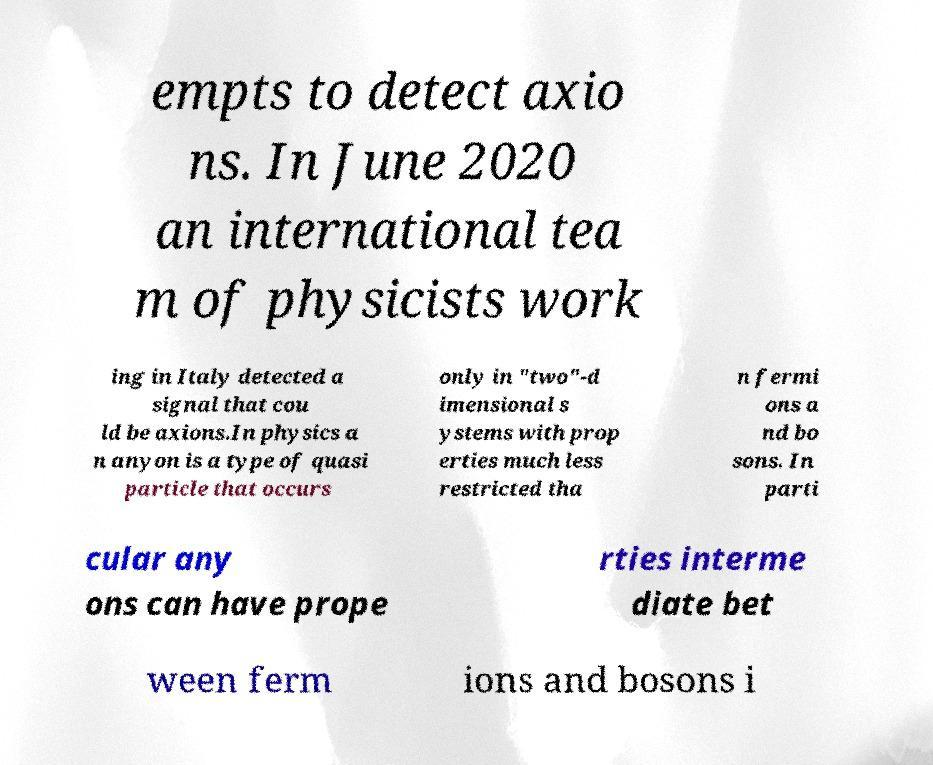Please read and relay the text visible in this image. What does it say? empts to detect axio ns. In June 2020 an international tea m of physicists work ing in Italy detected a signal that cou ld be axions.In physics a n anyon is a type of quasi particle that occurs only in "two"-d imensional s ystems with prop erties much less restricted tha n fermi ons a nd bo sons. In parti cular any ons can have prope rties interme diate bet ween ferm ions and bosons i 